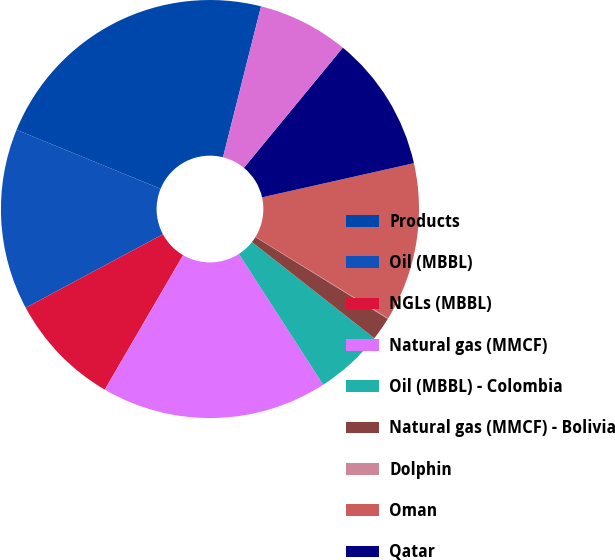<chart> <loc_0><loc_0><loc_500><loc_500><pie_chart><fcel>Products<fcel>Oil (MBBL)<fcel>NGLs (MBBL)<fcel>Natural gas (MMCF)<fcel>Oil (MBBL) - Colombia<fcel>Natural gas (MMCF) - Bolivia<fcel>Dolphin<fcel>Oman<fcel>Qatar<fcel>Other<nl><fcel>22.74%<fcel>14.01%<fcel>8.78%<fcel>17.5%<fcel>5.29%<fcel>1.8%<fcel>0.05%<fcel>12.27%<fcel>10.52%<fcel>7.03%<nl></chart> 